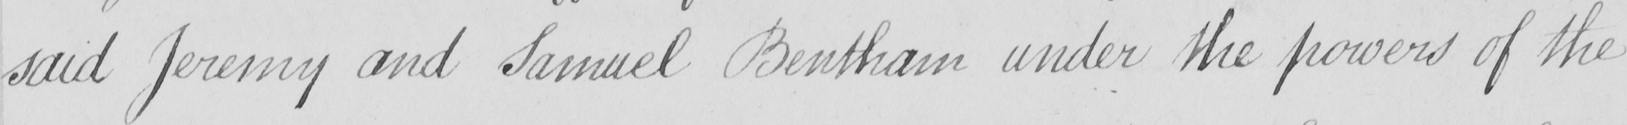What does this handwritten line say? said Jeremy and Samuel Bentham under the powers of the 